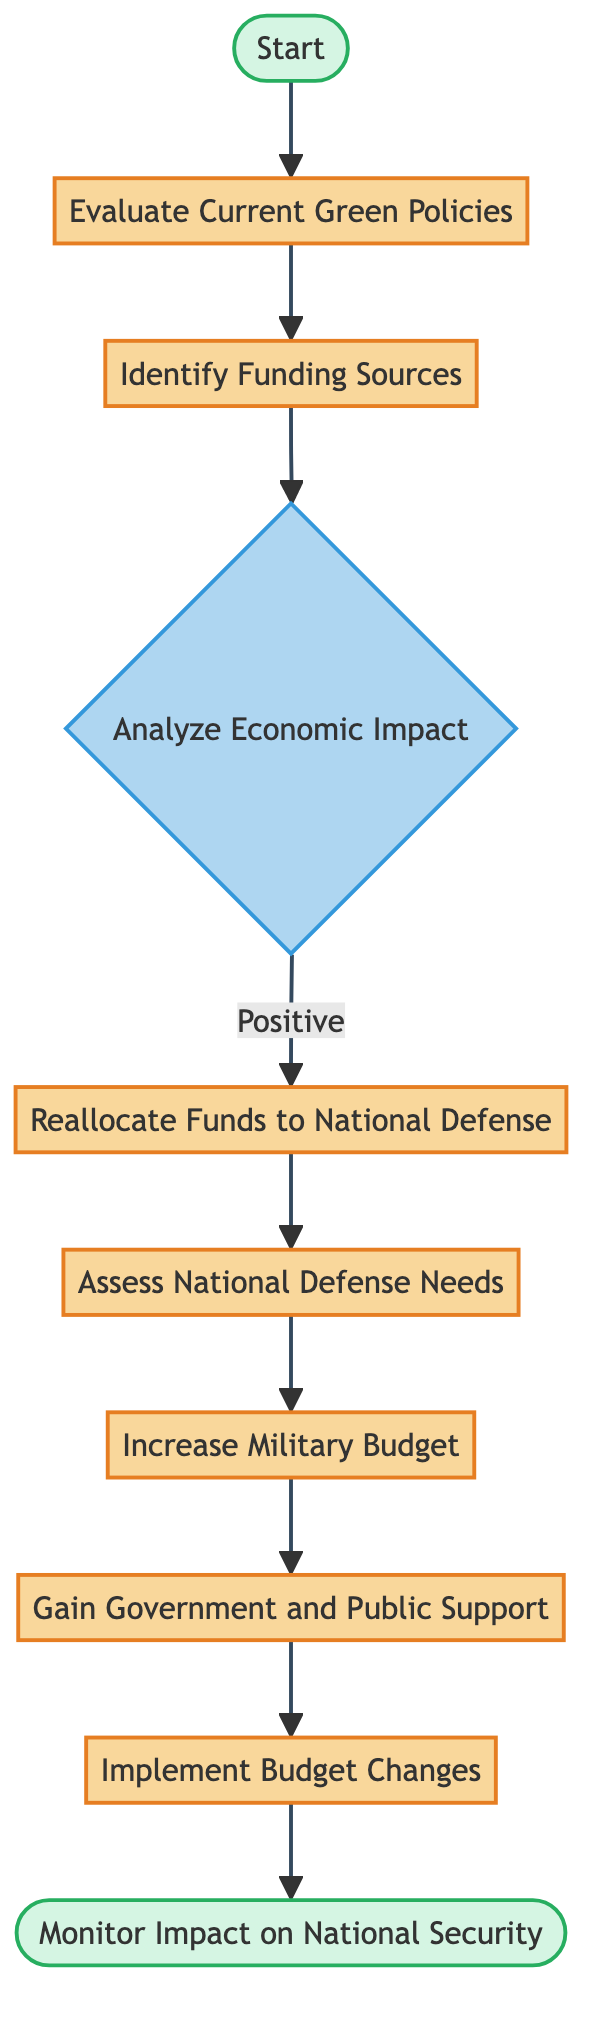What is the initial step in the process? The flow chart begins with the "Start" event, which serves as the initial point from which all actions and processes unfold.
Answer: Start How many decision points are present in the chart? There is one decision point in the chart, which is the "Analyze Economic Impact" node. This node has multiple options but represents a single decision-making point in the flow.
Answer: One What follows after identifying funding sources? After "Identify Funding Sources," the next step is "Analyze Economic Impact," which indicates the progression of the flow from funding sources towards evaluating their economic effects.
Answer: Analyze Economic Impact What happens if the economic impact is negative? If the economic impact is negative, the process does not indicate a clear alternative path; thus, it may suggest that no reallocation to national defense occurs, following the flow chart logic.
Answer: No reallocation Which step is the last in the flow chart? The final step of the flow chart is "Monitor Impact on National Security," indicating the conclusion of the process where outcomes are assessed after implementing changes.
Answer: Monitor Impact on National Security What process directly follows reallocating funds? The process that follows "Reallocate Funds to National Defense" is "Assess National Defense Needs," indicating the natural progression from funding allocation to determining defense requirements.
Answer: Assess National Defense Needs What is the purpose of gaining government and public support? "Gain Government and Public Support" is a critical step aimed at ensuring that the subsequent actions, including budget changes, have the necessary backing from stakeholders to be successful in implementation.
Answer: Ensure backing How many processes are in the flow chart? The flow chart contains seven processes, which include evaluating, identifying, reallocating, assessing, increasing, gaining support, and implementing changes.
Answer: Seven 